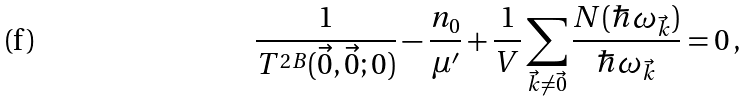Convert formula to latex. <formula><loc_0><loc_0><loc_500><loc_500>\frac { 1 } { T ^ { 2 B } ( \vec { 0 } , \vec { 0 } ; 0 ) } - \frac { n _ { 0 } } { \mu ^ { \prime } } + \frac { 1 } { V } \sum _ { \vec { k } \neq \vec { 0 } } \frac { N ( \hbar { \omega } _ { \vec { k } } ) } { \hbar { \omega } _ { \vec { k } } } = 0 \, ,</formula> 